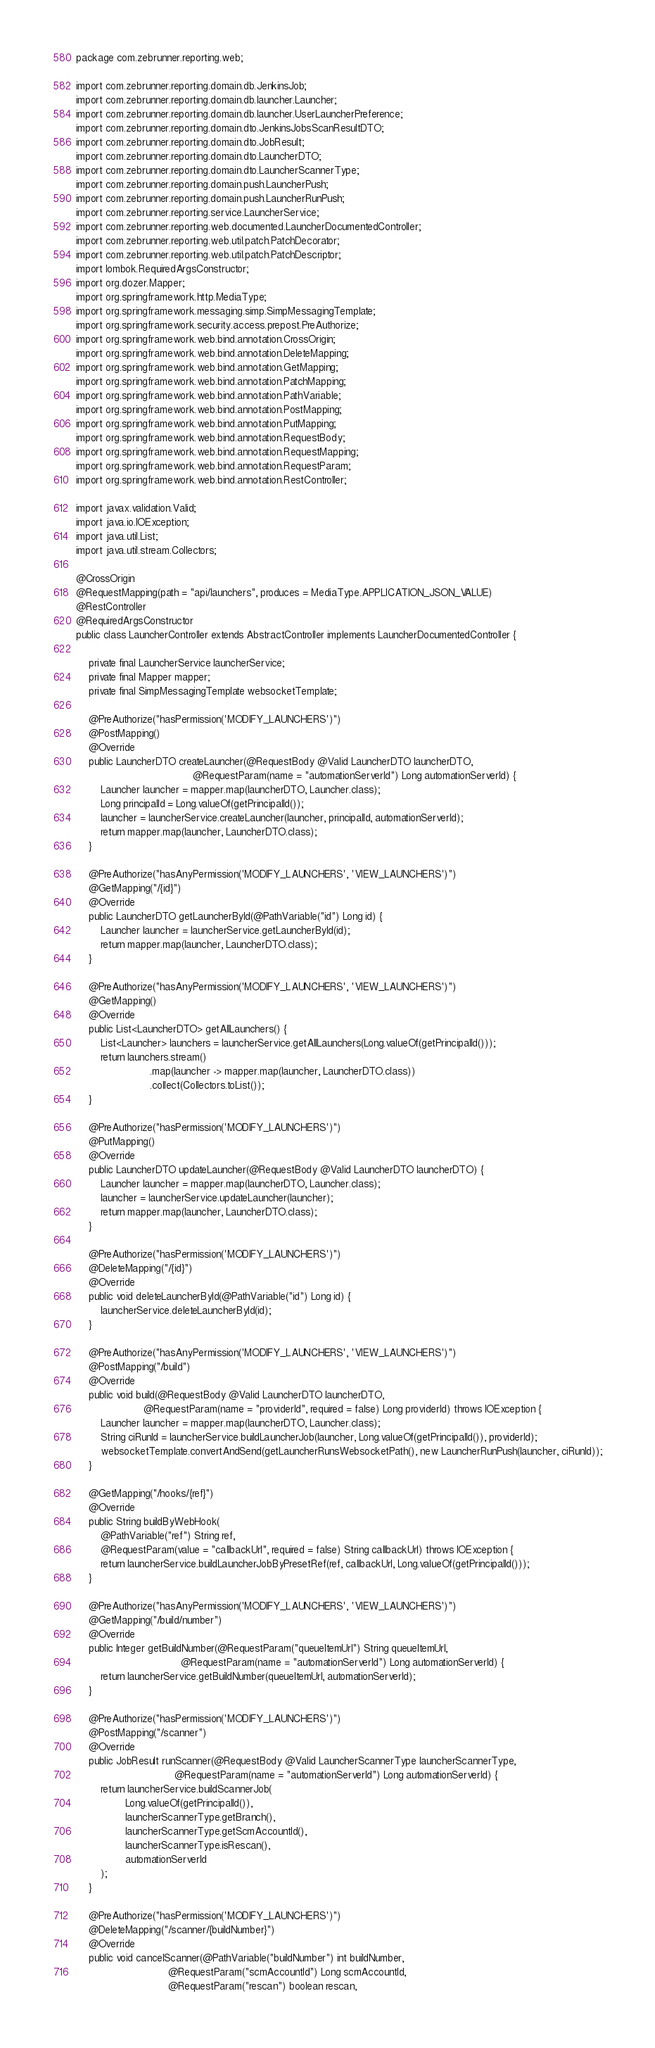Convert code to text. <code><loc_0><loc_0><loc_500><loc_500><_Java_>package com.zebrunner.reporting.web;

import com.zebrunner.reporting.domain.db.JenkinsJob;
import com.zebrunner.reporting.domain.db.launcher.Launcher;
import com.zebrunner.reporting.domain.db.launcher.UserLauncherPreference;
import com.zebrunner.reporting.domain.dto.JenkinsJobsScanResultDTO;
import com.zebrunner.reporting.domain.dto.JobResult;
import com.zebrunner.reporting.domain.dto.LauncherDTO;
import com.zebrunner.reporting.domain.dto.LauncherScannerType;
import com.zebrunner.reporting.domain.push.LauncherPush;
import com.zebrunner.reporting.domain.push.LauncherRunPush;
import com.zebrunner.reporting.service.LauncherService;
import com.zebrunner.reporting.web.documented.LauncherDocumentedController;
import com.zebrunner.reporting.web.util.patch.PatchDecorator;
import com.zebrunner.reporting.web.util.patch.PatchDescriptor;
import lombok.RequiredArgsConstructor;
import org.dozer.Mapper;
import org.springframework.http.MediaType;
import org.springframework.messaging.simp.SimpMessagingTemplate;
import org.springframework.security.access.prepost.PreAuthorize;
import org.springframework.web.bind.annotation.CrossOrigin;
import org.springframework.web.bind.annotation.DeleteMapping;
import org.springframework.web.bind.annotation.GetMapping;
import org.springframework.web.bind.annotation.PatchMapping;
import org.springframework.web.bind.annotation.PathVariable;
import org.springframework.web.bind.annotation.PostMapping;
import org.springframework.web.bind.annotation.PutMapping;
import org.springframework.web.bind.annotation.RequestBody;
import org.springframework.web.bind.annotation.RequestMapping;
import org.springframework.web.bind.annotation.RequestParam;
import org.springframework.web.bind.annotation.RestController;

import javax.validation.Valid;
import java.io.IOException;
import java.util.List;
import java.util.stream.Collectors;

@CrossOrigin
@RequestMapping(path = "api/launchers", produces = MediaType.APPLICATION_JSON_VALUE)
@RestController
@RequiredArgsConstructor
public class LauncherController extends AbstractController implements LauncherDocumentedController {

    private final LauncherService launcherService;
    private final Mapper mapper;
    private final SimpMessagingTemplate websocketTemplate;

    @PreAuthorize("hasPermission('MODIFY_LAUNCHERS')")
    @PostMapping()
    @Override
    public LauncherDTO createLauncher(@RequestBody @Valid LauncherDTO launcherDTO,
                                      @RequestParam(name = "automationServerId") Long automationServerId) {
        Launcher launcher = mapper.map(launcherDTO, Launcher.class);
        Long principalId = Long.valueOf(getPrincipalId());
        launcher = launcherService.createLauncher(launcher, principalId, automationServerId);
        return mapper.map(launcher, LauncherDTO.class);
    }

    @PreAuthorize("hasAnyPermission('MODIFY_LAUNCHERS', 'VIEW_LAUNCHERS')")
    @GetMapping("/{id}")
    @Override
    public LauncherDTO getLauncherById(@PathVariable("id") Long id) {
        Launcher launcher = launcherService.getLauncherById(id);
        return mapper.map(launcher, LauncherDTO.class);
    }

    @PreAuthorize("hasAnyPermission('MODIFY_LAUNCHERS', 'VIEW_LAUNCHERS')")
    @GetMapping()
    @Override
    public List<LauncherDTO> getAllLaunchers() {
        List<Launcher> launchers = launcherService.getAllLaunchers(Long.valueOf(getPrincipalId()));
        return launchers.stream()
                        .map(launcher -> mapper.map(launcher, LauncherDTO.class))
                        .collect(Collectors.toList());
    }

    @PreAuthorize("hasPermission('MODIFY_LAUNCHERS')")
    @PutMapping()
    @Override
    public LauncherDTO updateLauncher(@RequestBody @Valid LauncherDTO launcherDTO) {
        Launcher launcher = mapper.map(launcherDTO, Launcher.class);
        launcher = launcherService.updateLauncher(launcher);
        return mapper.map(launcher, LauncherDTO.class);
    }

    @PreAuthorize("hasPermission('MODIFY_LAUNCHERS')")
    @DeleteMapping("/{id}")
    @Override
    public void deleteLauncherById(@PathVariable("id") Long id) {
        launcherService.deleteLauncherById(id);
    }

    @PreAuthorize("hasAnyPermission('MODIFY_LAUNCHERS', 'VIEW_LAUNCHERS')")
    @PostMapping("/build")
    @Override
    public void build(@RequestBody @Valid LauncherDTO launcherDTO,
                      @RequestParam(name = "providerId", required = false) Long providerId) throws IOException {
        Launcher launcher = mapper.map(launcherDTO, Launcher.class);
        String ciRunId = launcherService.buildLauncherJob(launcher, Long.valueOf(getPrincipalId()), providerId);
        websocketTemplate.convertAndSend(getLauncherRunsWebsocketPath(), new LauncherRunPush(launcher, ciRunId));
    }

    @GetMapping("/hooks/{ref}")
    @Override
    public String buildByWebHook(
        @PathVariable("ref") String ref,
        @RequestParam(value = "callbackUrl", required = false) String callbackUrl) throws IOException {
        return launcherService.buildLauncherJobByPresetRef(ref, callbackUrl, Long.valueOf(getPrincipalId()));
    }

    @PreAuthorize("hasAnyPermission('MODIFY_LAUNCHERS', 'VIEW_LAUNCHERS')")
    @GetMapping("/build/number")
    @Override
    public Integer getBuildNumber(@RequestParam("queueItemUrl") String queueItemUrl,
                                  @RequestParam(name = "automationServerId") Long automationServerId) {
        return launcherService.getBuildNumber(queueItemUrl, automationServerId);
    }

    @PreAuthorize("hasPermission('MODIFY_LAUNCHERS')")
    @PostMapping("/scanner")
    @Override
    public JobResult runScanner(@RequestBody @Valid LauncherScannerType launcherScannerType,
                                @RequestParam(name = "automationServerId") Long automationServerId) {
        return launcherService.buildScannerJob(
                Long.valueOf(getPrincipalId()),
                launcherScannerType.getBranch(),
                launcherScannerType.getScmAccountId(),
                launcherScannerType.isRescan(),
                automationServerId
        );
    }

    @PreAuthorize("hasPermission('MODIFY_LAUNCHERS')")
    @DeleteMapping("/scanner/{buildNumber}")
    @Override
    public void cancelScanner(@PathVariable("buildNumber") int buildNumber,
                              @RequestParam("scmAccountId") Long scmAccountId,
                              @RequestParam("rescan") boolean rescan,</code> 